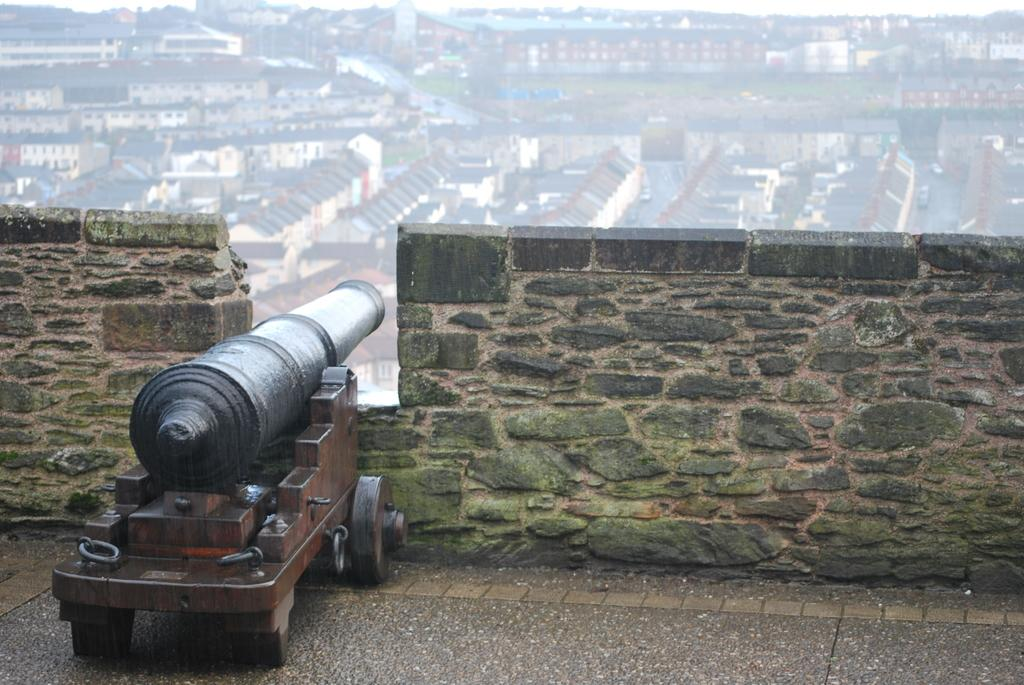What is on the trolley that is visible in the image? There is a weapon on a trolley in the image. Where is the trolley located in the image? The trolley is on the floor in the image. What can be seen behind the trolley in the image? There is a wall visible in the image. What is visible at the top of the image? There are buildings at the top of the image. What is the surface that the trolley is placed on in the image? The floor is visible in the image. How many sisters are visible in the image? There are no sisters present in the image. What color is the sky in the image? The provided facts do not mention the sky, so we cannot determine its color from the image. 